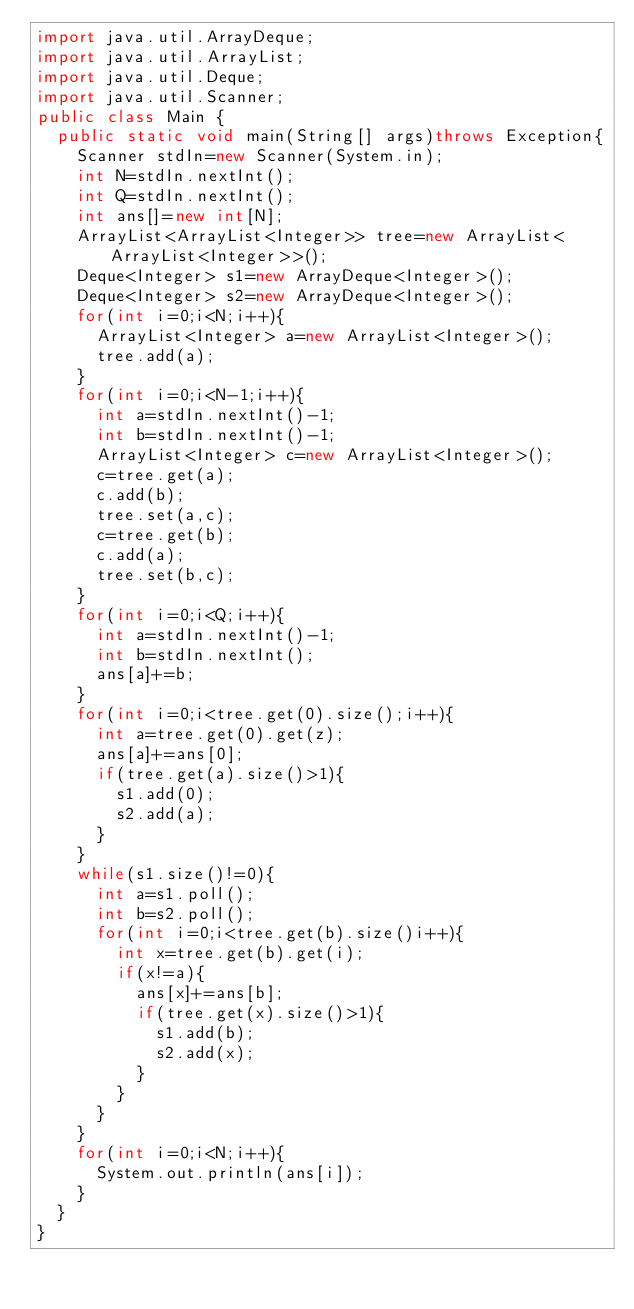Convert code to text. <code><loc_0><loc_0><loc_500><loc_500><_Java_>import java.util.ArrayDeque;
import java.util.ArrayList;
import java.util.Deque;
import java.util.Scanner;
public class Main {
	public static void main(String[] args)throws Exception{
		Scanner stdIn=new Scanner(System.in);
		int N=stdIn.nextInt();
		int Q=stdIn.nextInt();
		int ans[]=new int[N];
		ArrayList<ArrayList<Integer>> tree=new ArrayList<ArrayList<Integer>>();
		Deque<Integer> s1=new ArrayDeque<Integer>();
		Deque<Integer> s2=new ArrayDeque<Integer>();
		for(int i=0;i<N;i++){
			ArrayList<Integer> a=new ArrayList<Integer>();
			tree.add(a);
		}
		for(int i=0;i<N-1;i++){
			int a=stdIn.nextInt()-1;
			int b=stdIn.nextInt()-1;
			ArrayList<Integer> c=new ArrayList<Integer>();
			c=tree.get(a);
			c.add(b);
			tree.set(a,c);
			c=tree.get(b);
			c.add(a);
			tree.set(b,c);
		}
		for(int i=0;i<Q;i++){
			int a=stdIn.nextInt()-1;
			int b=stdIn.nextInt();
			ans[a]+=b;
		}
		for(int i=0;i<tree.get(0).size();i++){
			int a=tree.get(0).get(z);
			ans[a]+=ans[0];
			if(tree.get(a).size()>1){
				s1.add(0);
				s2.add(a);
			}
		}
		while(s1.size()!=0){
			int a=s1.poll();
			int b=s2.poll();
			for(int i=0;i<tree.get(b).size()i++){
				int x=tree.get(b).get(i);
				if(x!=a){
					ans[x]+=ans[b];
					if(tree.get(x).size()>1){
						s1.add(b);
						s2.add(x);
					}
				}
			}
		}
		for(int i=0;i<N;i++){
			System.out.println(ans[i]);
		}
	}
}</code> 